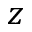<formula> <loc_0><loc_0><loc_500><loc_500>z</formula> 